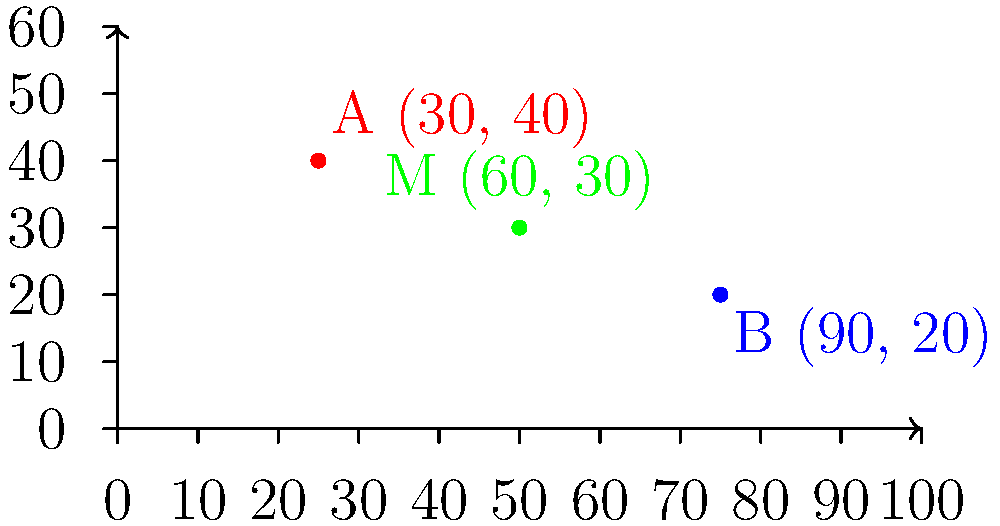During a crucial play in the Hamilton Tiger-Cats' season opener, receiver A is at position (30, 40) and quarterback B is at position (90, 20) on the stadium's coordinate grid (measured in yards). To execute a perfect pass, B needs to throw the ball to the midpoint between their positions. What are the coordinates of this midpoint M? To find the midpoint M between two points A(x₁, y₁) and B(x₂, y₂), we use the midpoint formula:

$$ M_x = \frac{x_1 + x_2}{2}, \quad M_y = \frac{y_1 + y_2}{2} $$

Given:
- Point A: (30, 40)
- Point B: (90, 20)

Step 1: Calculate the x-coordinate of the midpoint:
$$ M_x = \frac{x_1 + x_2}{2} = \frac{30 + 90}{2} = \frac{120}{2} = 60 $$

Step 2: Calculate the y-coordinate of the midpoint:
$$ M_y = \frac{y_1 + y_2}{2} = \frac{40 + 20}{2} = \frac{60}{2} = 30 $$

Therefore, the coordinates of the midpoint M are (60, 30).
Answer: (60, 30) 